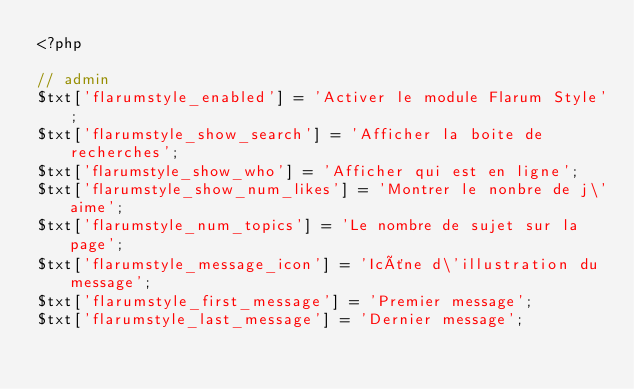Convert code to text. <code><loc_0><loc_0><loc_500><loc_500><_PHP_><?php

// admin
$txt['flarumstyle_enabled'] = 'Activer le module Flarum Style';
$txt['flarumstyle_show_search'] = 'Afficher la boite de recherches';
$txt['flarumstyle_show_who'] = 'Afficher qui est en ligne';
$txt['flarumstyle_show_num_likes'] = 'Montrer le nonbre de j\'aime';
$txt['flarumstyle_num_topics'] = 'Le nombre de sujet sur la page';
$txt['flarumstyle_message_icon'] = 'Icône d\'illustration du message';
$txt['flarumstyle_first_message'] = 'Premier message';
$txt['flarumstyle_last_message'] = 'Dernier message';
</code> 